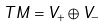Convert formula to latex. <formula><loc_0><loc_0><loc_500><loc_500>T M = V _ { + } \oplus V _ { - }</formula> 